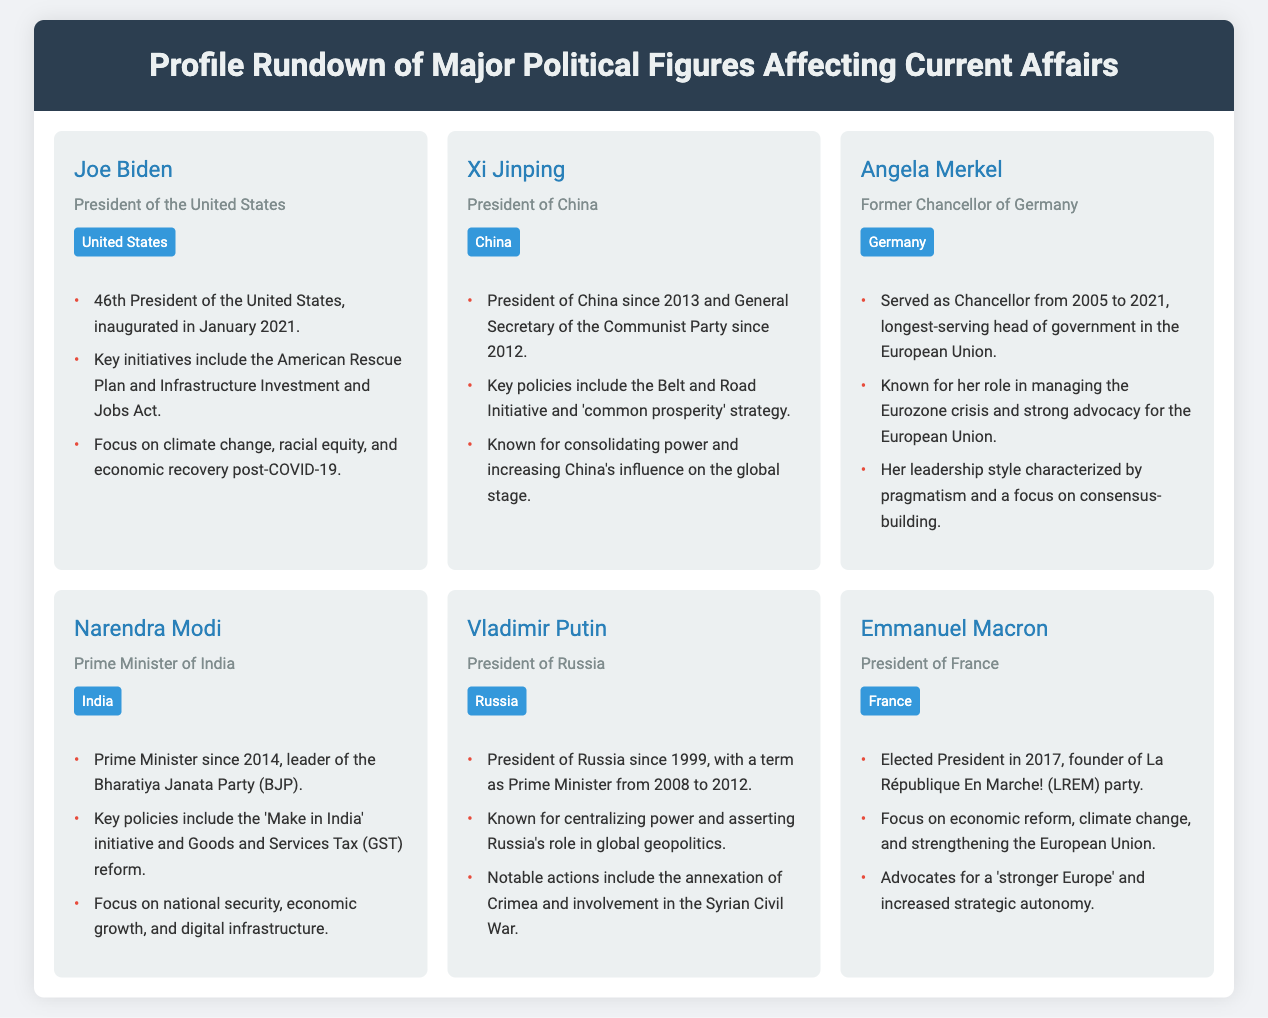What is the title of Joe Biden? Joe Biden is introduced as the President of the United States in the document.
Answer: President of the United States Who is the General Secretary of the Communist Party of China? Xi Jinping holds the position of General Secretary of the Communist Party since 2012 as stated in the document.
Answer: Xi Jinping How long did Angela Merkel serve as Chancellor of Germany? The document states that Angela Merkel served as Chancellor from 2005 to 2021, which totals 16 years.
Answer: 16 years What initiative is associated with Narendra Modi? The document mentions "Make in India" as a key initiative associated with Narendra Modi.
Answer: Make in India Which country does Emmanuel Macron preside over? Emmanuel Macron is noted as the President of France in the document.
Answer: France How many major political figures are listed in the document? There are six political figures highlighted in the profile rundown section of the document.
Answer: Six What is a common theme in the profiles of the figures? The document highlights initiatives and policies that focus on economic growth and global influence as a common theme.
Answer: Economic growth and global influence Which figure served the longest as head of government in the European Union? The document states Angela Merkel had the longest tenure as head of government in the European Union.
Answer: Angela Merkel What is the focus of Xi Jinping's key policies? The document describes Xi Jinping's policies focusing on the Belt and Road Initiative and 'common prosperity' strategy.
Answer: Belt and Road Initiative and 'common prosperity' strategy 